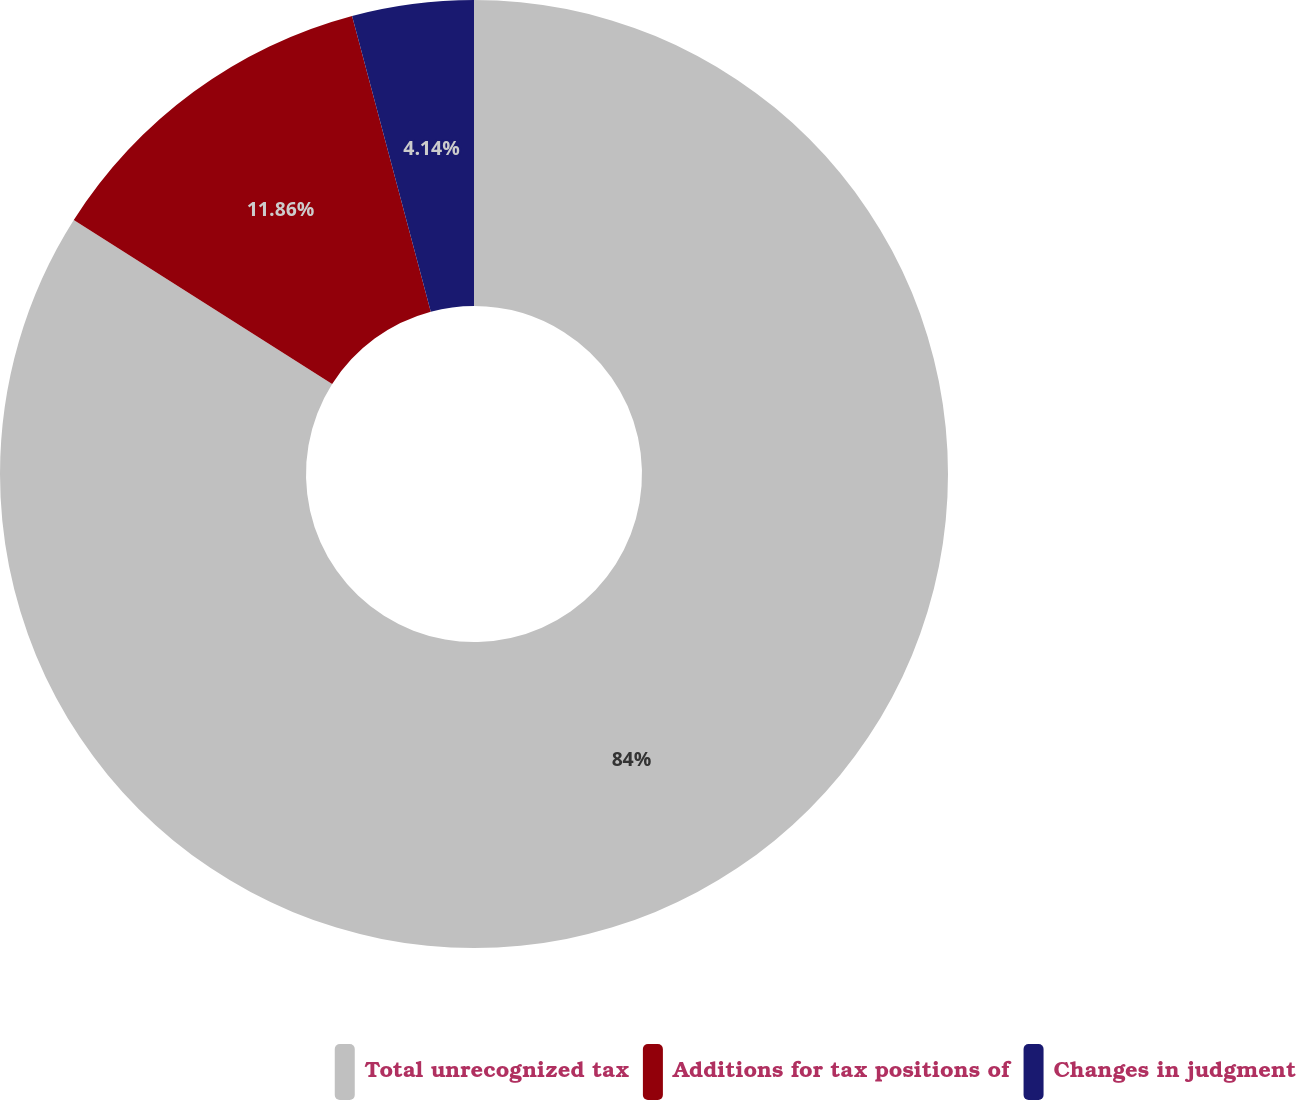Convert chart. <chart><loc_0><loc_0><loc_500><loc_500><pie_chart><fcel>Total unrecognized tax<fcel>Additions for tax positions of<fcel>Changes in judgment<nl><fcel>83.99%<fcel>11.86%<fcel>4.14%<nl></chart> 